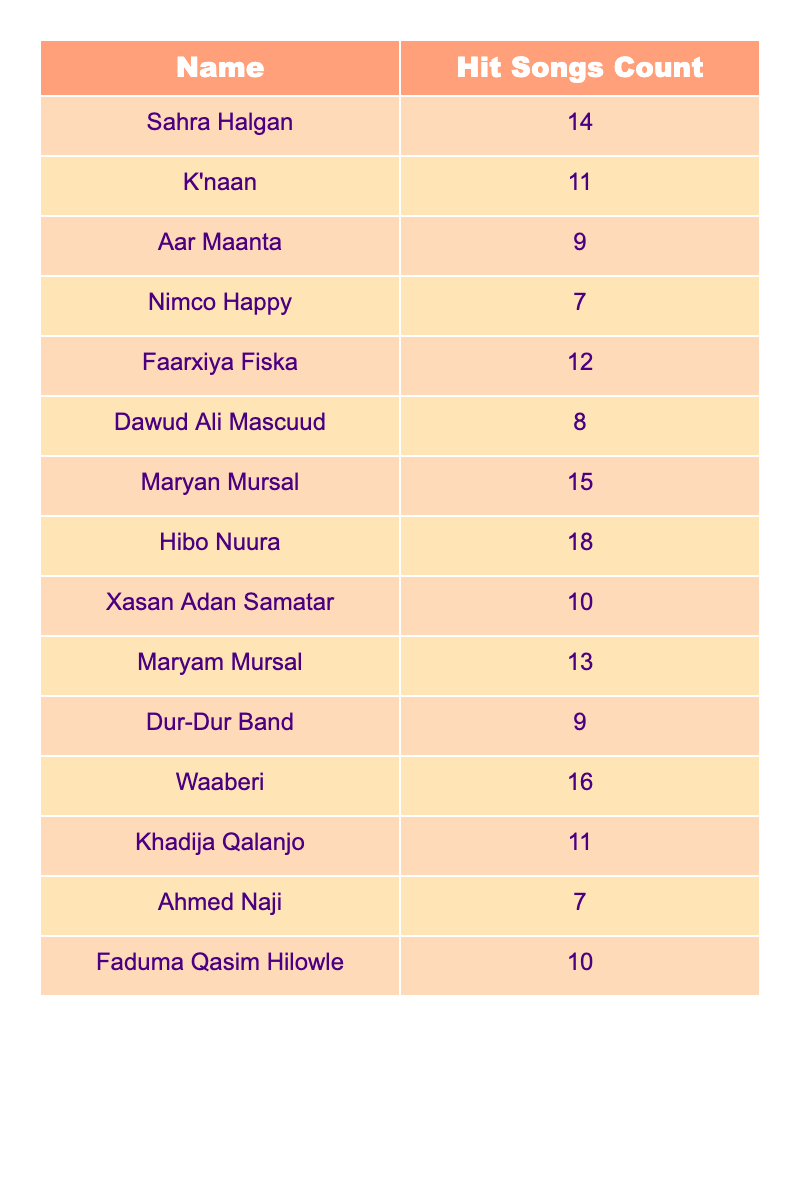What is the name of the musician with the highest hit song count? By inspecting the table, we see that Hibo Nuura has the highest hit song count with a total of 18 songs.
Answer: Hibo Nuura How many hit songs does Maryan Mursal have? The table lists Maryan Mursal with a hit song count of 15.
Answer: 15 Which musician has the lowest hit song count? Looking at the table, we find that both Ahmed Naji and Nimco Happy have the lowest hit song count, which is 7.
Answer: Ahmed Naji and Nimco Happy What is the total number of hit songs by Faarxiya Fiska and K'naan combined? Faarxiya Fiska has 12 hit songs, and K'naan has 11. Adding these together: 12 + 11 = 23.
Answer: 23 Is Waaberi's hit song count greater than 15? The table shows that Waaberi has a hit song count of 16, which is indeed greater than 15.
Answer: Yes Who are the musicians with hit song counts greater than 10? By reviewing the table, the musicians with more than 10 hit songs are Hibo Nuura (18), Waaberi (16), Maryan Mursal (15), Faarxiya Fiska (12), K'naan (11), and Khadija Qalanjo (11).
Answer: Hibo Nuura, Waaberi, Maryan Mursal, Faarxiya Fiska, K'naan, Khadija Qalanjo What is the average hit song count of the listed musicians? To calculate the average, sum all the hit song counts: 14 + 11 + 9 + 7 + 12 + 8 + 15 + 18 + 10 + 13 + 9 + 16 + 11 + 7 + 10 = 16. Then, we divide by the number of musicians (15): 16/15 = 10.67.
Answer: 10.67 How many more hit songs does Hibo Nuura have than Nimco Happy? Hibo Nuura has 18 hit songs and Nimco Happy has 7. So, we subtract: 18 - 7 = 11.
Answer: 11 What is the sum of the hit song counts of the top three musicians? The top three musicians based on hit songs are Hibo Nuura (18), Waaberi (16), and Maryan Mursal (15). Their total is 18 + 16 + 15 = 49.
Answer: 49 Does Faduma Qasim Hilowle have more hit songs than Xasan Adan Samatar? Faduma Qasim Hilowle has 10 hit songs, while Xasan Adan Samatar has 10 as well. So they are equal, which means Faduma does not have more.
Answer: No 